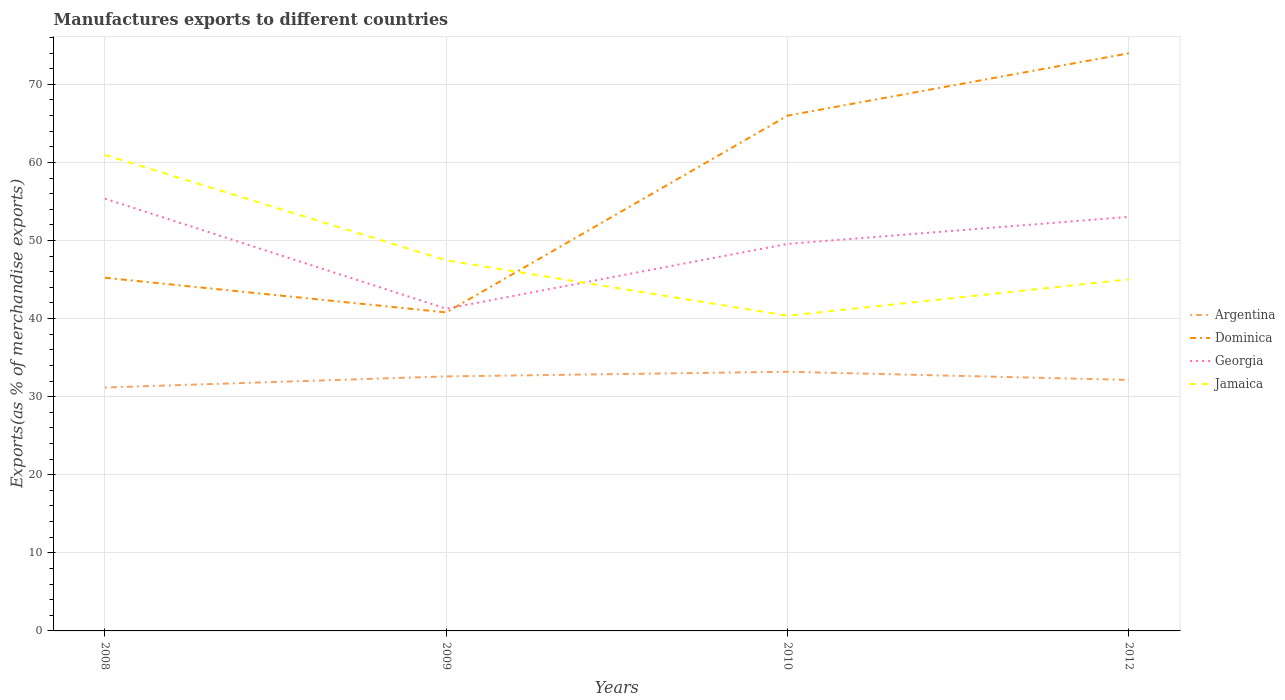How many different coloured lines are there?
Offer a very short reply. 4. Is the number of lines equal to the number of legend labels?
Offer a terse response. Yes. Across all years, what is the maximum percentage of exports to different countries in Argentina?
Your answer should be compact. 31.17. What is the total percentage of exports to different countries in Georgia in the graph?
Keep it short and to the point. -8.29. What is the difference between the highest and the second highest percentage of exports to different countries in Argentina?
Make the answer very short. 2.02. Is the percentage of exports to different countries in Jamaica strictly greater than the percentage of exports to different countries in Dominica over the years?
Offer a very short reply. No. Are the values on the major ticks of Y-axis written in scientific E-notation?
Offer a very short reply. No. Does the graph contain any zero values?
Provide a short and direct response. No. Where does the legend appear in the graph?
Ensure brevity in your answer.  Center right. How many legend labels are there?
Your response must be concise. 4. How are the legend labels stacked?
Keep it short and to the point. Vertical. What is the title of the graph?
Make the answer very short. Manufactures exports to different countries. What is the label or title of the X-axis?
Your answer should be compact. Years. What is the label or title of the Y-axis?
Your response must be concise. Exports(as % of merchandise exports). What is the Exports(as % of merchandise exports) of Argentina in 2008?
Your answer should be very brief. 31.17. What is the Exports(as % of merchandise exports) of Dominica in 2008?
Offer a terse response. 45.23. What is the Exports(as % of merchandise exports) of Georgia in 2008?
Ensure brevity in your answer.  55.36. What is the Exports(as % of merchandise exports) of Jamaica in 2008?
Make the answer very short. 60.97. What is the Exports(as % of merchandise exports) of Argentina in 2009?
Your answer should be very brief. 32.59. What is the Exports(as % of merchandise exports) of Dominica in 2009?
Make the answer very short. 40.79. What is the Exports(as % of merchandise exports) of Georgia in 2009?
Keep it short and to the point. 41.27. What is the Exports(as % of merchandise exports) in Jamaica in 2009?
Offer a terse response. 47.46. What is the Exports(as % of merchandise exports) in Argentina in 2010?
Offer a terse response. 33.19. What is the Exports(as % of merchandise exports) of Dominica in 2010?
Make the answer very short. 65.99. What is the Exports(as % of merchandise exports) in Georgia in 2010?
Provide a short and direct response. 49.56. What is the Exports(as % of merchandise exports) of Jamaica in 2010?
Provide a short and direct response. 40.37. What is the Exports(as % of merchandise exports) of Argentina in 2012?
Your answer should be very brief. 32.14. What is the Exports(as % of merchandise exports) in Dominica in 2012?
Offer a terse response. 73.97. What is the Exports(as % of merchandise exports) in Georgia in 2012?
Your answer should be very brief. 53.02. What is the Exports(as % of merchandise exports) in Jamaica in 2012?
Your answer should be very brief. 45.02. Across all years, what is the maximum Exports(as % of merchandise exports) of Argentina?
Keep it short and to the point. 33.19. Across all years, what is the maximum Exports(as % of merchandise exports) of Dominica?
Offer a terse response. 73.97. Across all years, what is the maximum Exports(as % of merchandise exports) in Georgia?
Provide a short and direct response. 55.36. Across all years, what is the maximum Exports(as % of merchandise exports) of Jamaica?
Offer a very short reply. 60.97. Across all years, what is the minimum Exports(as % of merchandise exports) in Argentina?
Offer a very short reply. 31.17. Across all years, what is the minimum Exports(as % of merchandise exports) in Dominica?
Give a very brief answer. 40.79. Across all years, what is the minimum Exports(as % of merchandise exports) of Georgia?
Your answer should be very brief. 41.27. Across all years, what is the minimum Exports(as % of merchandise exports) of Jamaica?
Keep it short and to the point. 40.37. What is the total Exports(as % of merchandise exports) in Argentina in the graph?
Provide a succinct answer. 129.1. What is the total Exports(as % of merchandise exports) of Dominica in the graph?
Your answer should be compact. 225.98. What is the total Exports(as % of merchandise exports) of Georgia in the graph?
Your response must be concise. 199.21. What is the total Exports(as % of merchandise exports) in Jamaica in the graph?
Your answer should be very brief. 193.81. What is the difference between the Exports(as % of merchandise exports) in Argentina in 2008 and that in 2009?
Give a very brief answer. -1.42. What is the difference between the Exports(as % of merchandise exports) of Dominica in 2008 and that in 2009?
Your answer should be compact. 4.44. What is the difference between the Exports(as % of merchandise exports) in Georgia in 2008 and that in 2009?
Offer a very short reply. 14.09. What is the difference between the Exports(as % of merchandise exports) of Jamaica in 2008 and that in 2009?
Give a very brief answer. 13.51. What is the difference between the Exports(as % of merchandise exports) of Argentina in 2008 and that in 2010?
Ensure brevity in your answer.  -2.02. What is the difference between the Exports(as % of merchandise exports) in Dominica in 2008 and that in 2010?
Ensure brevity in your answer.  -20.76. What is the difference between the Exports(as % of merchandise exports) of Georgia in 2008 and that in 2010?
Make the answer very short. 5.8. What is the difference between the Exports(as % of merchandise exports) in Jamaica in 2008 and that in 2010?
Ensure brevity in your answer.  20.6. What is the difference between the Exports(as % of merchandise exports) in Argentina in 2008 and that in 2012?
Your response must be concise. -0.97. What is the difference between the Exports(as % of merchandise exports) of Dominica in 2008 and that in 2012?
Ensure brevity in your answer.  -28.74. What is the difference between the Exports(as % of merchandise exports) in Georgia in 2008 and that in 2012?
Your answer should be very brief. 2.34. What is the difference between the Exports(as % of merchandise exports) of Jamaica in 2008 and that in 2012?
Give a very brief answer. 15.95. What is the difference between the Exports(as % of merchandise exports) of Argentina in 2009 and that in 2010?
Give a very brief answer. -0.6. What is the difference between the Exports(as % of merchandise exports) in Dominica in 2009 and that in 2010?
Offer a terse response. -25.2. What is the difference between the Exports(as % of merchandise exports) of Georgia in 2009 and that in 2010?
Make the answer very short. -8.29. What is the difference between the Exports(as % of merchandise exports) of Jamaica in 2009 and that in 2010?
Provide a succinct answer. 7.09. What is the difference between the Exports(as % of merchandise exports) of Argentina in 2009 and that in 2012?
Ensure brevity in your answer.  0.45. What is the difference between the Exports(as % of merchandise exports) in Dominica in 2009 and that in 2012?
Your answer should be very brief. -33.18. What is the difference between the Exports(as % of merchandise exports) of Georgia in 2009 and that in 2012?
Your response must be concise. -11.76. What is the difference between the Exports(as % of merchandise exports) in Jamaica in 2009 and that in 2012?
Keep it short and to the point. 2.44. What is the difference between the Exports(as % of merchandise exports) in Argentina in 2010 and that in 2012?
Keep it short and to the point. 1.05. What is the difference between the Exports(as % of merchandise exports) in Dominica in 2010 and that in 2012?
Your response must be concise. -7.98. What is the difference between the Exports(as % of merchandise exports) of Georgia in 2010 and that in 2012?
Ensure brevity in your answer.  -3.46. What is the difference between the Exports(as % of merchandise exports) of Jamaica in 2010 and that in 2012?
Your response must be concise. -4.65. What is the difference between the Exports(as % of merchandise exports) in Argentina in 2008 and the Exports(as % of merchandise exports) in Dominica in 2009?
Offer a terse response. -9.61. What is the difference between the Exports(as % of merchandise exports) in Argentina in 2008 and the Exports(as % of merchandise exports) in Georgia in 2009?
Make the answer very short. -10.09. What is the difference between the Exports(as % of merchandise exports) in Argentina in 2008 and the Exports(as % of merchandise exports) in Jamaica in 2009?
Your answer should be compact. -16.28. What is the difference between the Exports(as % of merchandise exports) of Dominica in 2008 and the Exports(as % of merchandise exports) of Georgia in 2009?
Your response must be concise. 3.96. What is the difference between the Exports(as % of merchandise exports) in Dominica in 2008 and the Exports(as % of merchandise exports) in Jamaica in 2009?
Your response must be concise. -2.23. What is the difference between the Exports(as % of merchandise exports) of Georgia in 2008 and the Exports(as % of merchandise exports) of Jamaica in 2009?
Offer a very short reply. 7.9. What is the difference between the Exports(as % of merchandise exports) in Argentina in 2008 and the Exports(as % of merchandise exports) in Dominica in 2010?
Your answer should be very brief. -34.82. What is the difference between the Exports(as % of merchandise exports) of Argentina in 2008 and the Exports(as % of merchandise exports) of Georgia in 2010?
Make the answer very short. -18.39. What is the difference between the Exports(as % of merchandise exports) of Argentina in 2008 and the Exports(as % of merchandise exports) of Jamaica in 2010?
Your answer should be very brief. -9.19. What is the difference between the Exports(as % of merchandise exports) in Dominica in 2008 and the Exports(as % of merchandise exports) in Georgia in 2010?
Give a very brief answer. -4.33. What is the difference between the Exports(as % of merchandise exports) of Dominica in 2008 and the Exports(as % of merchandise exports) of Jamaica in 2010?
Offer a terse response. 4.86. What is the difference between the Exports(as % of merchandise exports) of Georgia in 2008 and the Exports(as % of merchandise exports) of Jamaica in 2010?
Your response must be concise. 14.99. What is the difference between the Exports(as % of merchandise exports) of Argentina in 2008 and the Exports(as % of merchandise exports) of Dominica in 2012?
Ensure brevity in your answer.  -42.8. What is the difference between the Exports(as % of merchandise exports) in Argentina in 2008 and the Exports(as % of merchandise exports) in Georgia in 2012?
Your response must be concise. -21.85. What is the difference between the Exports(as % of merchandise exports) of Argentina in 2008 and the Exports(as % of merchandise exports) of Jamaica in 2012?
Your answer should be very brief. -13.84. What is the difference between the Exports(as % of merchandise exports) in Dominica in 2008 and the Exports(as % of merchandise exports) in Georgia in 2012?
Offer a very short reply. -7.79. What is the difference between the Exports(as % of merchandise exports) of Dominica in 2008 and the Exports(as % of merchandise exports) of Jamaica in 2012?
Offer a terse response. 0.21. What is the difference between the Exports(as % of merchandise exports) of Georgia in 2008 and the Exports(as % of merchandise exports) of Jamaica in 2012?
Your response must be concise. 10.34. What is the difference between the Exports(as % of merchandise exports) in Argentina in 2009 and the Exports(as % of merchandise exports) in Dominica in 2010?
Provide a succinct answer. -33.4. What is the difference between the Exports(as % of merchandise exports) in Argentina in 2009 and the Exports(as % of merchandise exports) in Georgia in 2010?
Ensure brevity in your answer.  -16.97. What is the difference between the Exports(as % of merchandise exports) in Argentina in 2009 and the Exports(as % of merchandise exports) in Jamaica in 2010?
Offer a very short reply. -7.77. What is the difference between the Exports(as % of merchandise exports) in Dominica in 2009 and the Exports(as % of merchandise exports) in Georgia in 2010?
Offer a very short reply. -8.77. What is the difference between the Exports(as % of merchandise exports) in Dominica in 2009 and the Exports(as % of merchandise exports) in Jamaica in 2010?
Provide a short and direct response. 0.42. What is the difference between the Exports(as % of merchandise exports) in Georgia in 2009 and the Exports(as % of merchandise exports) in Jamaica in 2010?
Offer a very short reply. 0.9. What is the difference between the Exports(as % of merchandise exports) of Argentina in 2009 and the Exports(as % of merchandise exports) of Dominica in 2012?
Offer a very short reply. -41.38. What is the difference between the Exports(as % of merchandise exports) in Argentina in 2009 and the Exports(as % of merchandise exports) in Georgia in 2012?
Your response must be concise. -20.43. What is the difference between the Exports(as % of merchandise exports) of Argentina in 2009 and the Exports(as % of merchandise exports) of Jamaica in 2012?
Your response must be concise. -12.42. What is the difference between the Exports(as % of merchandise exports) in Dominica in 2009 and the Exports(as % of merchandise exports) in Georgia in 2012?
Make the answer very short. -12.23. What is the difference between the Exports(as % of merchandise exports) in Dominica in 2009 and the Exports(as % of merchandise exports) in Jamaica in 2012?
Make the answer very short. -4.23. What is the difference between the Exports(as % of merchandise exports) of Georgia in 2009 and the Exports(as % of merchandise exports) of Jamaica in 2012?
Offer a terse response. -3.75. What is the difference between the Exports(as % of merchandise exports) in Argentina in 2010 and the Exports(as % of merchandise exports) in Dominica in 2012?
Offer a very short reply. -40.78. What is the difference between the Exports(as % of merchandise exports) in Argentina in 2010 and the Exports(as % of merchandise exports) in Georgia in 2012?
Your answer should be compact. -19.83. What is the difference between the Exports(as % of merchandise exports) of Argentina in 2010 and the Exports(as % of merchandise exports) of Jamaica in 2012?
Offer a terse response. -11.83. What is the difference between the Exports(as % of merchandise exports) in Dominica in 2010 and the Exports(as % of merchandise exports) in Georgia in 2012?
Your answer should be compact. 12.97. What is the difference between the Exports(as % of merchandise exports) of Dominica in 2010 and the Exports(as % of merchandise exports) of Jamaica in 2012?
Your answer should be compact. 20.97. What is the difference between the Exports(as % of merchandise exports) of Georgia in 2010 and the Exports(as % of merchandise exports) of Jamaica in 2012?
Provide a succinct answer. 4.54. What is the average Exports(as % of merchandise exports) in Argentina per year?
Offer a terse response. 32.27. What is the average Exports(as % of merchandise exports) in Dominica per year?
Give a very brief answer. 56.49. What is the average Exports(as % of merchandise exports) in Georgia per year?
Offer a terse response. 49.8. What is the average Exports(as % of merchandise exports) in Jamaica per year?
Make the answer very short. 48.45. In the year 2008, what is the difference between the Exports(as % of merchandise exports) in Argentina and Exports(as % of merchandise exports) in Dominica?
Ensure brevity in your answer.  -14.05. In the year 2008, what is the difference between the Exports(as % of merchandise exports) of Argentina and Exports(as % of merchandise exports) of Georgia?
Ensure brevity in your answer.  -24.19. In the year 2008, what is the difference between the Exports(as % of merchandise exports) in Argentina and Exports(as % of merchandise exports) in Jamaica?
Provide a succinct answer. -29.79. In the year 2008, what is the difference between the Exports(as % of merchandise exports) in Dominica and Exports(as % of merchandise exports) in Georgia?
Give a very brief answer. -10.13. In the year 2008, what is the difference between the Exports(as % of merchandise exports) in Dominica and Exports(as % of merchandise exports) in Jamaica?
Your answer should be very brief. -15.74. In the year 2008, what is the difference between the Exports(as % of merchandise exports) of Georgia and Exports(as % of merchandise exports) of Jamaica?
Your answer should be very brief. -5.61. In the year 2009, what is the difference between the Exports(as % of merchandise exports) in Argentina and Exports(as % of merchandise exports) in Dominica?
Keep it short and to the point. -8.19. In the year 2009, what is the difference between the Exports(as % of merchandise exports) of Argentina and Exports(as % of merchandise exports) of Georgia?
Make the answer very short. -8.67. In the year 2009, what is the difference between the Exports(as % of merchandise exports) of Argentina and Exports(as % of merchandise exports) of Jamaica?
Your answer should be compact. -14.86. In the year 2009, what is the difference between the Exports(as % of merchandise exports) of Dominica and Exports(as % of merchandise exports) of Georgia?
Offer a very short reply. -0.48. In the year 2009, what is the difference between the Exports(as % of merchandise exports) of Dominica and Exports(as % of merchandise exports) of Jamaica?
Your response must be concise. -6.67. In the year 2009, what is the difference between the Exports(as % of merchandise exports) in Georgia and Exports(as % of merchandise exports) in Jamaica?
Provide a succinct answer. -6.19. In the year 2010, what is the difference between the Exports(as % of merchandise exports) in Argentina and Exports(as % of merchandise exports) in Dominica?
Make the answer very short. -32.8. In the year 2010, what is the difference between the Exports(as % of merchandise exports) of Argentina and Exports(as % of merchandise exports) of Georgia?
Keep it short and to the point. -16.37. In the year 2010, what is the difference between the Exports(as % of merchandise exports) of Argentina and Exports(as % of merchandise exports) of Jamaica?
Your answer should be compact. -7.18. In the year 2010, what is the difference between the Exports(as % of merchandise exports) in Dominica and Exports(as % of merchandise exports) in Georgia?
Your response must be concise. 16.43. In the year 2010, what is the difference between the Exports(as % of merchandise exports) in Dominica and Exports(as % of merchandise exports) in Jamaica?
Keep it short and to the point. 25.62. In the year 2010, what is the difference between the Exports(as % of merchandise exports) in Georgia and Exports(as % of merchandise exports) in Jamaica?
Offer a terse response. 9.19. In the year 2012, what is the difference between the Exports(as % of merchandise exports) in Argentina and Exports(as % of merchandise exports) in Dominica?
Provide a succinct answer. -41.83. In the year 2012, what is the difference between the Exports(as % of merchandise exports) in Argentina and Exports(as % of merchandise exports) in Georgia?
Offer a terse response. -20.88. In the year 2012, what is the difference between the Exports(as % of merchandise exports) of Argentina and Exports(as % of merchandise exports) of Jamaica?
Offer a very short reply. -12.88. In the year 2012, what is the difference between the Exports(as % of merchandise exports) of Dominica and Exports(as % of merchandise exports) of Georgia?
Offer a terse response. 20.95. In the year 2012, what is the difference between the Exports(as % of merchandise exports) of Dominica and Exports(as % of merchandise exports) of Jamaica?
Ensure brevity in your answer.  28.96. In the year 2012, what is the difference between the Exports(as % of merchandise exports) in Georgia and Exports(as % of merchandise exports) in Jamaica?
Offer a terse response. 8.01. What is the ratio of the Exports(as % of merchandise exports) of Argentina in 2008 to that in 2009?
Ensure brevity in your answer.  0.96. What is the ratio of the Exports(as % of merchandise exports) of Dominica in 2008 to that in 2009?
Provide a short and direct response. 1.11. What is the ratio of the Exports(as % of merchandise exports) of Georgia in 2008 to that in 2009?
Your answer should be compact. 1.34. What is the ratio of the Exports(as % of merchandise exports) of Jamaica in 2008 to that in 2009?
Your answer should be very brief. 1.28. What is the ratio of the Exports(as % of merchandise exports) in Argentina in 2008 to that in 2010?
Your answer should be very brief. 0.94. What is the ratio of the Exports(as % of merchandise exports) of Dominica in 2008 to that in 2010?
Your answer should be very brief. 0.69. What is the ratio of the Exports(as % of merchandise exports) in Georgia in 2008 to that in 2010?
Offer a very short reply. 1.12. What is the ratio of the Exports(as % of merchandise exports) in Jamaica in 2008 to that in 2010?
Provide a succinct answer. 1.51. What is the ratio of the Exports(as % of merchandise exports) in Argentina in 2008 to that in 2012?
Your answer should be compact. 0.97. What is the ratio of the Exports(as % of merchandise exports) of Dominica in 2008 to that in 2012?
Offer a very short reply. 0.61. What is the ratio of the Exports(as % of merchandise exports) of Georgia in 2008 to that in 2012?
Offer a very short reply. 1.04. What is the ratio of the Exports(as % of merchandise exports) of Jamaica in 2008 to that in 2012?
Your response must be concise. 1.35. What is the ratio of the Exports(as % of merchandise exports) in Argentina in 2009 to that in 2010?
Make the answer very short. 0.98. What is the ratio of the Exports(as % of merchandise exports) of Dominica in 2009 to that in 2010?
Ensure brevity in your answer.  0.62. What is the ratio of the Exports(as % of merchandise exports) of Georgia in 2009 to that in 2010?
Ensure brevity in your answer.  0.83. What is the ratio of the Exports(as % of merchandise exports) in Jamaica in 2009 to that in 2010?
Keep it short and to the point. 1.18. What is the ratio of the Exports(as % of merchandise exports) of Argentina in 2009 to that in 2012?
Your answer should be compact. 1.01. What is the ratio of the Exports(as % of merchandise exports) of Dominica in 2009 to that in 2012?
Your response must be concise. 0.55. What is the ratio of the Exports(as % of merchandise exports) of Georgia in 2009 to that in 2012?
Your answer should be very brief. 0.78. What is the ratio of the Exports(as % of merchandise exports) of Jamaica in 2009 to that in 2012?
Keep it short and to the point. 1.05. What is the ratio of the Exports(as % of merchandise exports) of Argentina in 2010 to that in 2012?
Give a very brief answer. 1.03. What is the ratio of the Exports(as % of merchandise exports) of Dominica in 2010 to that in 2012?
Provide a short and direct response. 0.89. What is the ratio of the Exports(as % of merchandise exports) of Georgia in 2010 to that in 2012?
Give a very brief answer. 0.93. What is the ratio of the Exports(as % of merchandise exports) in Jamaica in 2010 to that in 2012?
Offer a very short reply. 0.9. What is the difference between the highest and the second highest Exports(as % of merchandise exports) of Argentina?
Keep it short and to the point. 0.6. What is the difference between the highest and the second highest Exports(as % of merchandise exports) of Dominica?
Offer a very short reply. 7.98. What is the difference between the highest and the second highest Exports(as % of merchandise exports) of Georgia?
Provide a succinct answer. 2.34. What is the difference between the highest and the second highest Exports(as % of merchandise exports) of Jamaica?
Keep it short and to the point. 13.51. What is the difference between the highest and the lowest Exports(as % of merchandise exports) of Argentina?
Offer a terse response. 2.02. What is the difference between the highest and the lowest Exports(as % of merchandise exports) in Dominica?
Your answer should be compact. 33.18. What is the difference between the highest and the lowest Exports(as % of merchandise exports) of Georgia?
Give a very brief answer. 14.09. What is the difference between the highest and the lowest Exports(as % of merchandise exports) of Jamaica?
Give a very brief answer. 20.6. 